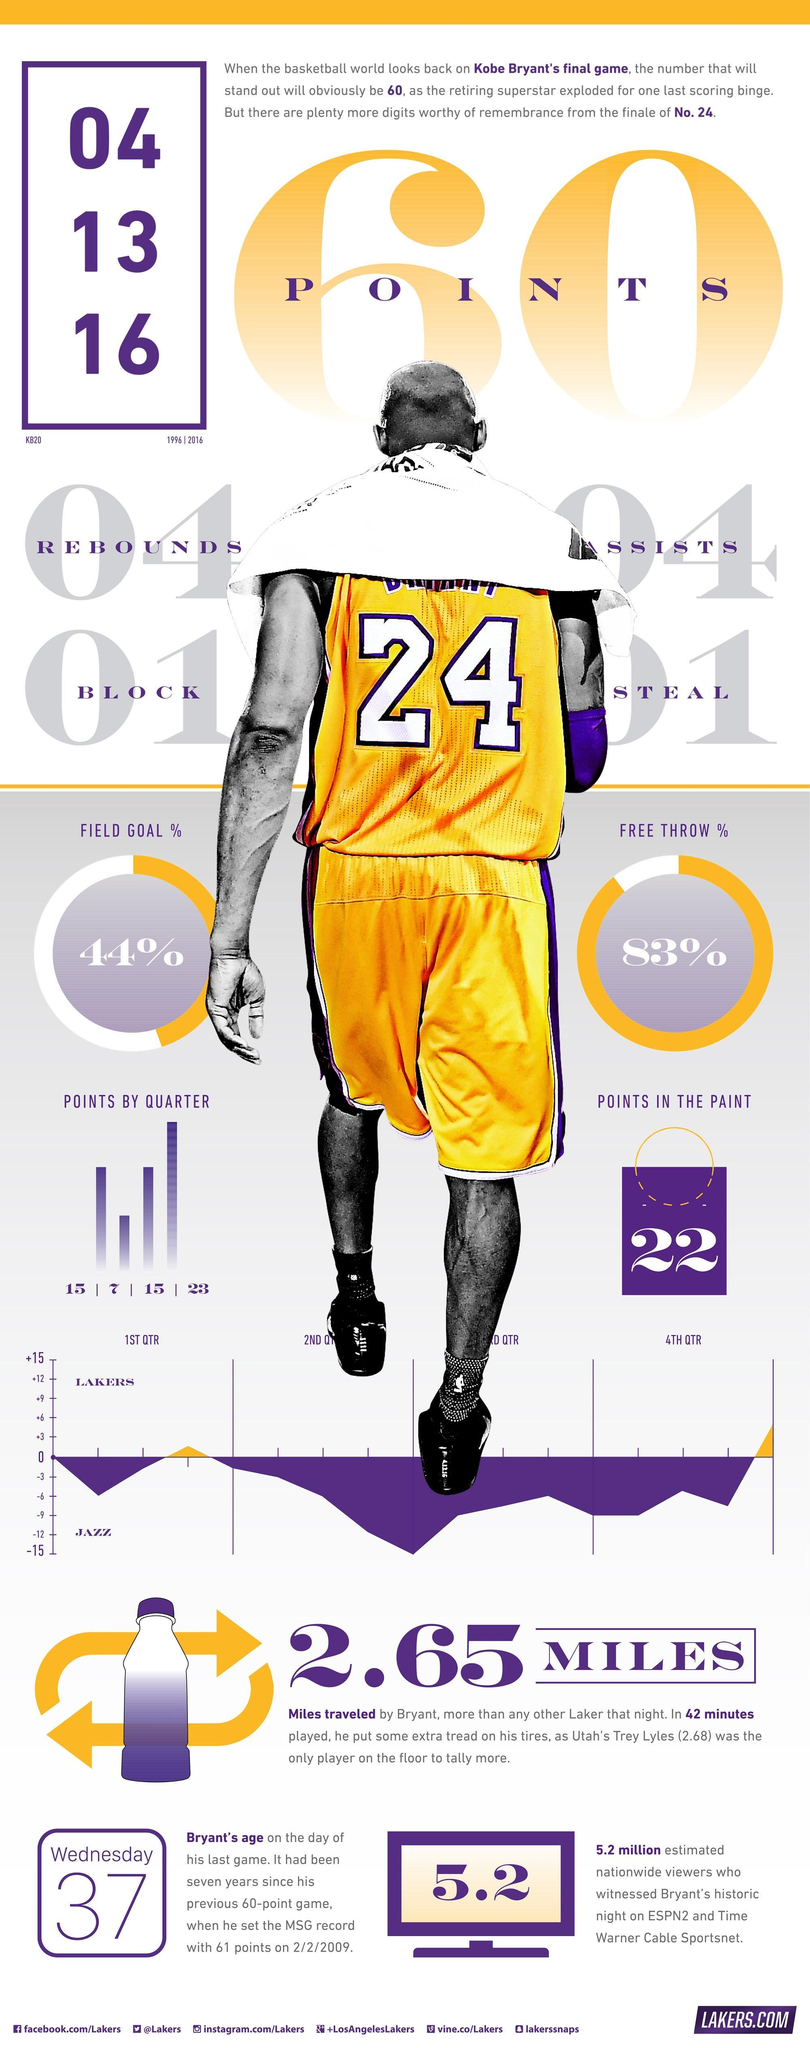What was Kobe Bryants field goal percentage in his final game?
Answer the question with a short phrase. 44% How old was Kobe Bryant when he played his last game? 37 How many points Kobe Bryant scored in his last game? 60 Which basketball team does Kobe Bryant play for? LAKERS How many points were scored by Kobe Bryant during the first quarter of his final game? 15 When did Kobe Bryant played his last game? 04 13 16 How many points were scored by Kobe Bryant during the fourth quarter of his final game? 23 What is Kobe Bryant's free throw percentage in his final game? 83% How many points did Kobe Bryant score in the paint in his last game? 22 What is the jersey number of Kobe Bryant? 24 